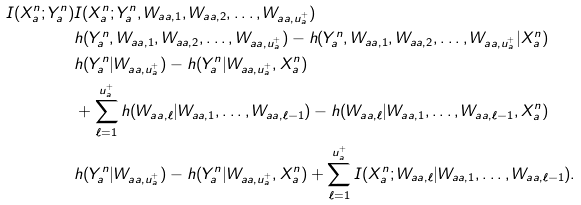Convert formula to latex. <formula><loc_0><loc_0><loc_500><loc_500>I ( X _ { a } ^ { n } ; Y _ { a } ^ { n } ) & I ( X _ { a } ^ { n } ; Y _ { a } ^ { n } , W _ { a a , 1 } , W _ { a a , 2 } , \dots , W _ { a a , u _ { a } ^ { + } } ) \\ & h ( Y _ { a } ^ { n } , W _ { a a , 1 } , W _ { a a , 2 } , \dots , W _ { a a , u _ { a } ^ { + } } ) - h ( Y _ { a } ^ { n } , W _ { a a , 1 } , W _ { a a , 2 } , \dots , W _ { a a , u _ { a } ^ { + } } | X _ { a } ^ { n } ) \\ & h ( Y _ { a } ^ { n } | W _ { a a , u _ { a } ^ { + } } ) - h ( Y _ { a } ^ { n } | W _ { a a , u _ { a } ^ { + } } , X _ { a } ^ { n } ) \\ & + \sum _ { \ell = 1 } ^ { u _ { a } ^ { + } } h ( W _ { a a , \ell } | W _ { a a , 1 } , \dots , W _ { a a , \ell - 1 } ) - h ( W _ { a a , \ell } | W _ { a a , 1 } , \dots , W _ { a a , \ell - 1 } , X _ { a } ^ { n } ) \\ & h ( Y _ { a } ^ { n } | W _ { a a , u _ { a } ^ { + } } ) - h ( Y _ { a } ^ { n } | W _ { a a , u _ { a } ^ { + } } , X _ { a } ^ { n } ) + \sum _ { \ell = 1 } ^ { u _ { a } ^ { + } } I ( X _ { a } ^ { n } ; W _ { a a , \ell } | W _ { a a , 1 } , \dots , W _ { a a , \ell - 1 } ) .</formula> 